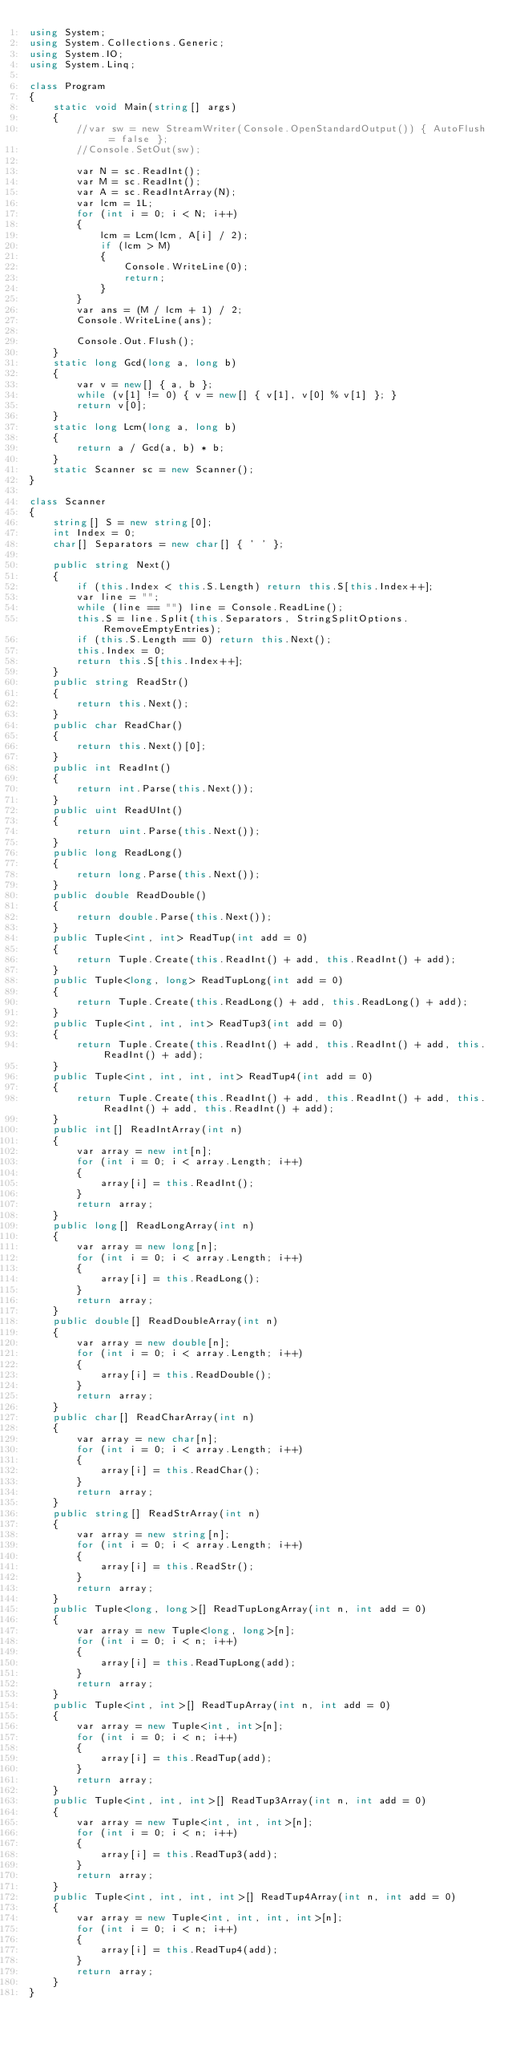<code> <loc_0><loc_0><loc_500><loc_500><_C#_>using System;
using System.Collections.Generic;
using System.IO;
using System.Linq;

class Program
{
    static void Main(string[] args)
    {
        //var sw = new StreamWriter(Console.OpenStandardOutput()) { AutoFlush = false };
        //Console.SetOut(sw);

        var N = sc.ReadInt();
        var M = sc.ReadInt();
        var A = sc.ReadIntArray(N);
        var lcm = 1L;
        for (int i = 0; i < N; i++)
        {
            lcm = Lcm(lcm, A[i] / 2);
            if (lcm > M)
            {
                Console.WriteLine(0);
                return;
            }
        }
        var ans = (M / lcm + 1) / 2;
        Console.WriteLine(ans);

        Console.Out.Flush();
    }
    static long Gcd(long a, long b)
    {
        var v = new[] { a, b };
        while (v[1] != 0) { v = new[] { v[1], v[0] % v[1] }; }
        return v[0];
    }
    static long Lcm(long a, long b)
    {
        return a / Gcd(a, b) * b;
    }
    static Scanner sc = new Scanner();
}

class Scanner
{
    string[] S = new string[0];
    int Index = 0;
    char[] Separators = new char[] { ' ' };

    public string Next()
    {
        if (this.Index < this.S.Length) return this.S[this.Index++];
        var line = "";
        while (line == "") line = Console.ReadLine();
        this.S = line.Split(this.Separators, StringSplitOptions.RemoveEmptyEntries);
        if (this.S.Length == 0) return this.Next();
        this.Index = 0;
        return this.S[this.Index++];
    }
    public string ReadStr()
    {
        return this.Next();
    }
    public char ReadChar()
    {
        return this.Next()[0];
    }
    public int ReadInt()
    {
        return int.Parse(this.Next());
    }
    public uint ReadUInt()
    {
        return uint.Parse(this.Next());
    }
    public long ReadLong()
    {
        return long.Parse(this.Next());
    }
    public double ReadDouble()
    {
        return double.Parse(this.Next());
    }
    public Tuple<int, int> ReadTup(int add = 0)
    {
        return Tuple.Create(this.ReadInt() + add, this.ReadInt() + add);
    }
    public Tuple<long, long> ReadTupLong(int add = 0)
    {
        return Tuple.Create(this.ReadLong() + add, this.ReadLong() + add);
    }
    public Tuple<int, int, int> ReadTup3(int add = 0)
    {
        return Tuple.Create(this.ReadInt() + add, this.ReadInt() + add, this.ReadInt() + add);
    }
    public Tuple<int, int, int, int> ReadTup4(int add = 0)
    {
        return Tuple.Create(this.ReadInt() + add, this.ReadInt() + add, this.ReadInt() + add, this.ReadInt() + add);
    }
    public int[] ReadIntArray(int n)
    {
        var array = new int[n];
        for (int i = 0; i < array.Length; i++)
        {
            array[i] = this.ReadInt();
        }
        return array;
    }
    public long[] ReadLongArray(int n)
    {
        var array = new long[n];
        for (int i = 0; i < array.Length; i++)
        {
            array[i] = this.ReadLong();
        }
        return array;
    }
    public double[] ReadDoubleArray(int n)
    {
        var array = new double[n];
        for (int i = 0; i < array.Length; i++)
        {
            array[i] = this.ReadDouble();
        }
        return array;
    }
    public char[] ReadCharArray(int n)
    {
        var array = new char[n];
        for (int i = 0; i < array.Length; i++)
        {
            array[i] = this.ReadChar();
        }
        return array;
    }
    public string[] ReadStrArray(int n)
    {
        var array = new string[n];
        for (int i = 0; i < array.Length; i++)
        {
            array[i] = this.ReadStr();
        }
        return array;
    }
    public Tuple<long, long>[] ReadTupLongArray(int n, int add = 0)
    {
        var array = new Tuple<long, long>[n];
        for (int i = 0; i < n; i++)
        {
            array[i] = this.ReadTupLong(add);
        }
        return array;
    }
    public Tuple<int, int>[] ReadTupArray(int n, int add = 0)
    {
        var array = new Tuple<int, int>[n];
        for (int i = 0; i < n; i++)
        {
            array[i] = this.ReadTup(add);
        }
        return array;
    }
    public Tuple<int, int, int>[] ReadTup3Array(int n, int add = 0)
    {
        var array = new Tuple<int, int, int>[n];
        for (int i = 0; i < n; i++)
        {
            array[i] = this.ReadTup3(add);
        }
        return array;
    }
    public Tuple<int, int, int, int>[] ReadTup4Array(int n, int add = 0)
    {
        var array = new Tuple<int, int, int, int>[n];
        for (int i = 0; i < n; i++)
        {
            array[i] = this.ReadTup4(add);
        }
        return array;
    }
}
</code> 